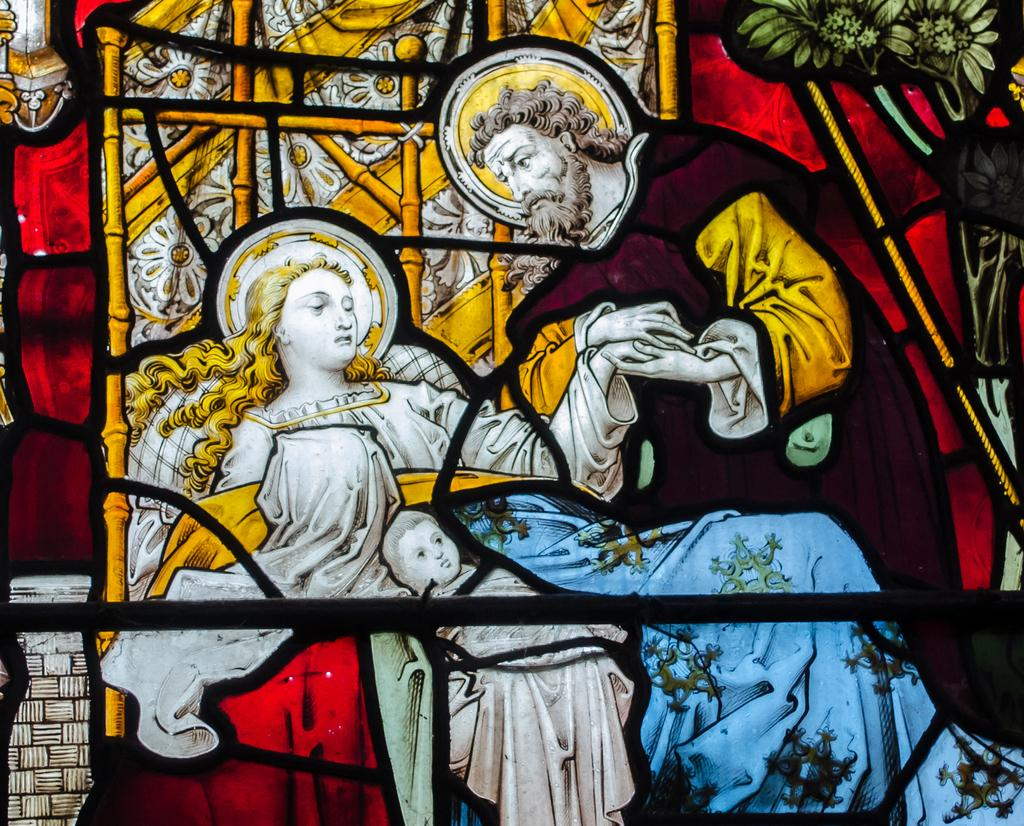What is the main subject of the painting in the image? The main subject of the painting in the image is persons. What other elements can be seen in the painting? Flowers are visible in the top right corner of the image, and there are sticks visible behind the persons. What type of cup is being used to drink eggnog in the image? There is no cup or eggnog present in the image; it features a painting of persons with flowers and sticks. 